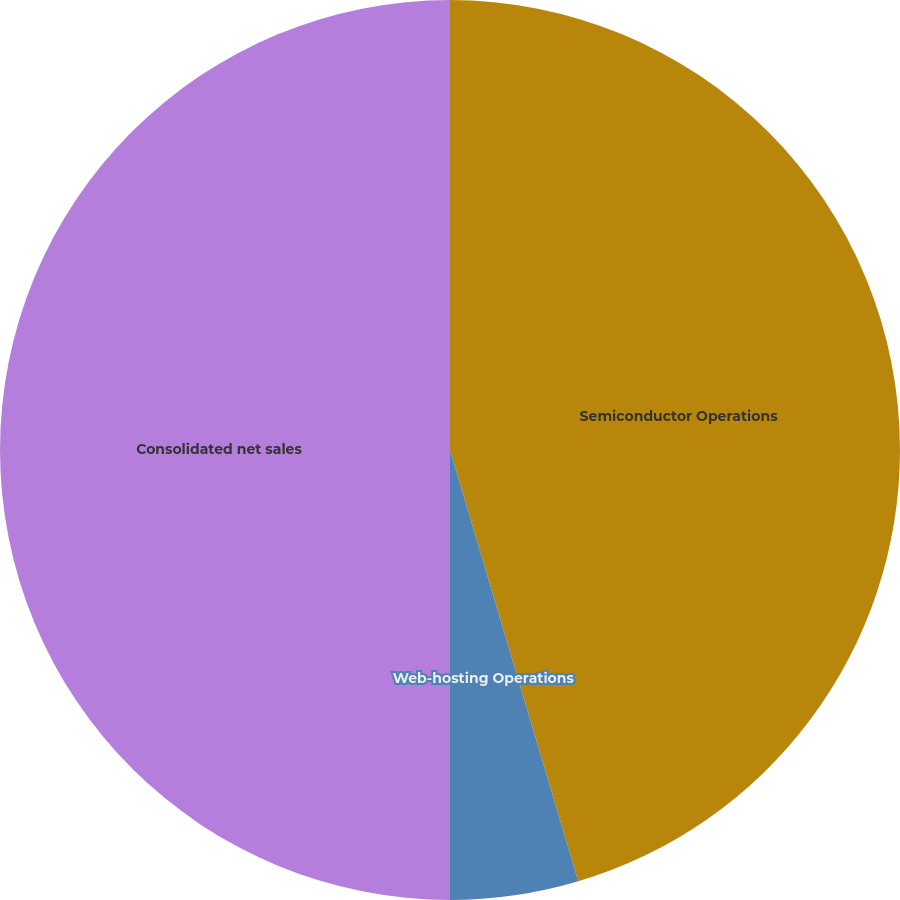<chart> <loc_0><loc_0><loc_500><loc_500><pie_chart><fcel>Semiconductor Operations<fcel>Web-hosting Operations<fcel>Other<fcel>Consolidated net sales<nl><fcel>45.4%<fcel>4.6%<fcel>0.0%<fcel>50.0%<nl></chart> 